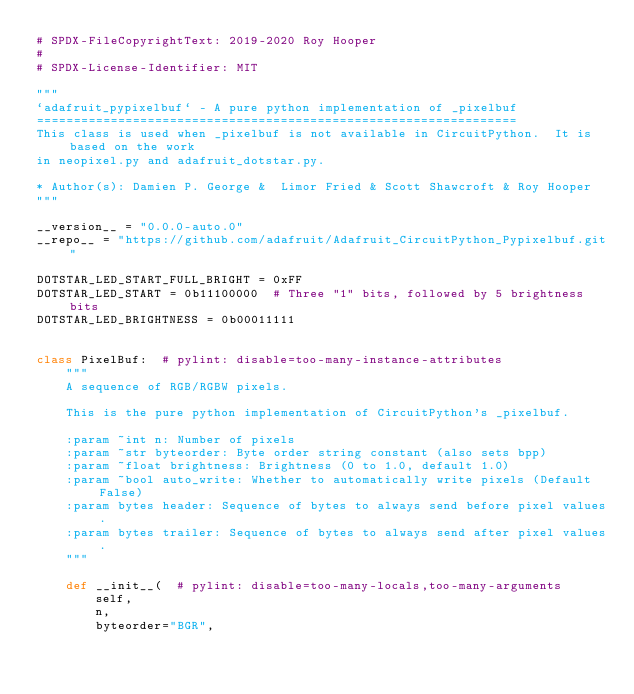Convert code to text. <code><loc_0><loc_0><loc_500><loc_500><_Python_># SPDX-FileCopyrightText: 2019-2020 Roy Hooper
#
# SPDX-License-Identifier: MIT

"""
`adafruit_pypixelbuf` - A pure python implementation of _pixelbuf
=================================================================
This class is used when _pixelbuf is not available in CircuitPython.  It is based on the work
in neopixel.py and adafruit_dotstar.py.

* Author(s): Damien P. George &  Limor Fried & Scott Shawcroft & Roy Hooper
"""

__version__ = "0.0.0-auto.0"
__repo__ = "https://github.com/adafruit/Adafruit_CircuitPython_Pypixelbuf.git"

DOTSTAR_LED_START_FULL_BRIGHT = 0xFF
DOTSTAR_LED_START = 0b11100000  # Three "1" bits, followed by 5 brightness bits
DOTSTAR_LED_BRIGHTNESS = 0b00011111


class PixelBuf:  # pylint: disable=too-many-instance-attributes
    """
    A sequence of RGB/RGBW pixels.

    This is the pure python implementation of CircuitPython's _pixelbuf.

    :param ~int n: Number of pixels
    :param ~str byteorder: Byte order string constant (also sets bpp)
    :param ~float brightness: Brightness (0 to 1.0, default 1.0)
    :param ~bool auto_write: Whether to automatically write pixels (Default False)
    :param bytes header: Sequence of bytes to always send before pixel values.
    :param bytes trailer: Sequence of bytes to always send after pixel values.
    """

    def __init__(  # pylint: disable=too-many-locals,too-many-arguments
        self,
        n,
        byteorder="BGR",</code> 